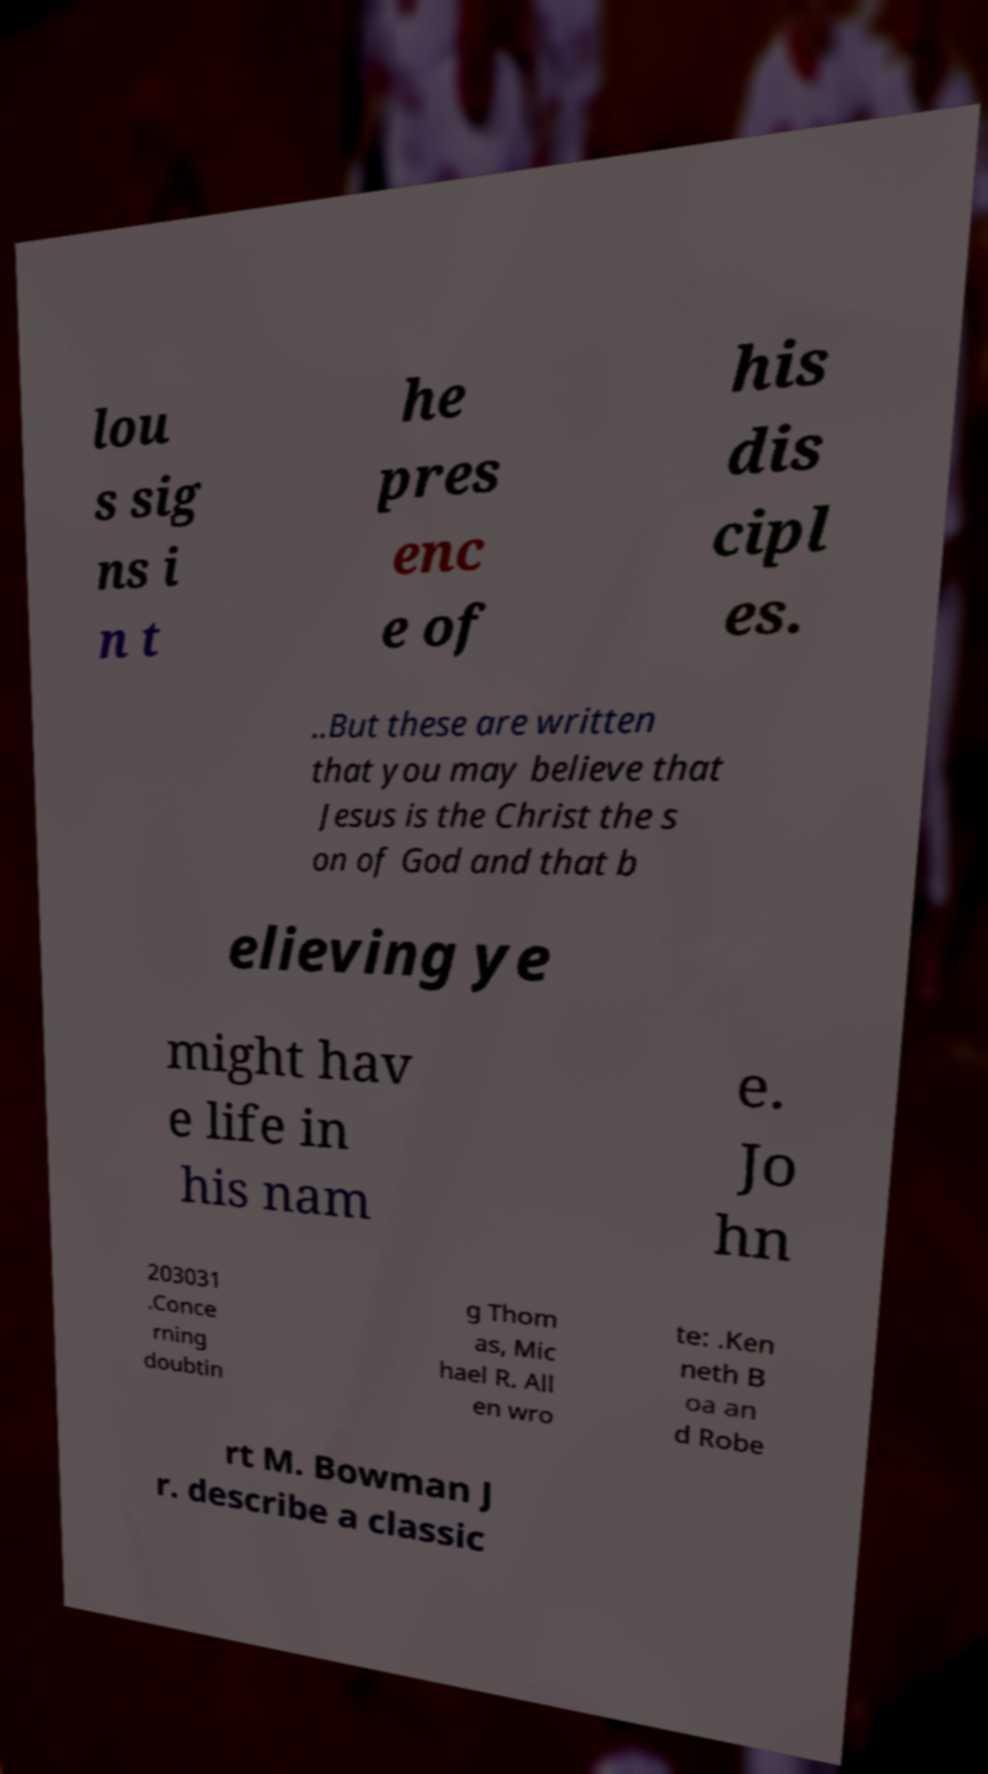Can you read and provide the text displayed in the image?This photo seems to have some interesting text. Can you extract and type it out for me? lou s sig ns i n t he pres enc e of his dis cipl es. ..But these are written that you may believe that Jesus is the Christ the s on of God and that b elieving ye might hav e life in his nam e. Jo hn 203031 .Conce rning doubtin g Thom as, Mic hael R. All en wro te: .Ken neth B oa an d Robe rt M. Bowman J r. describe a classic 